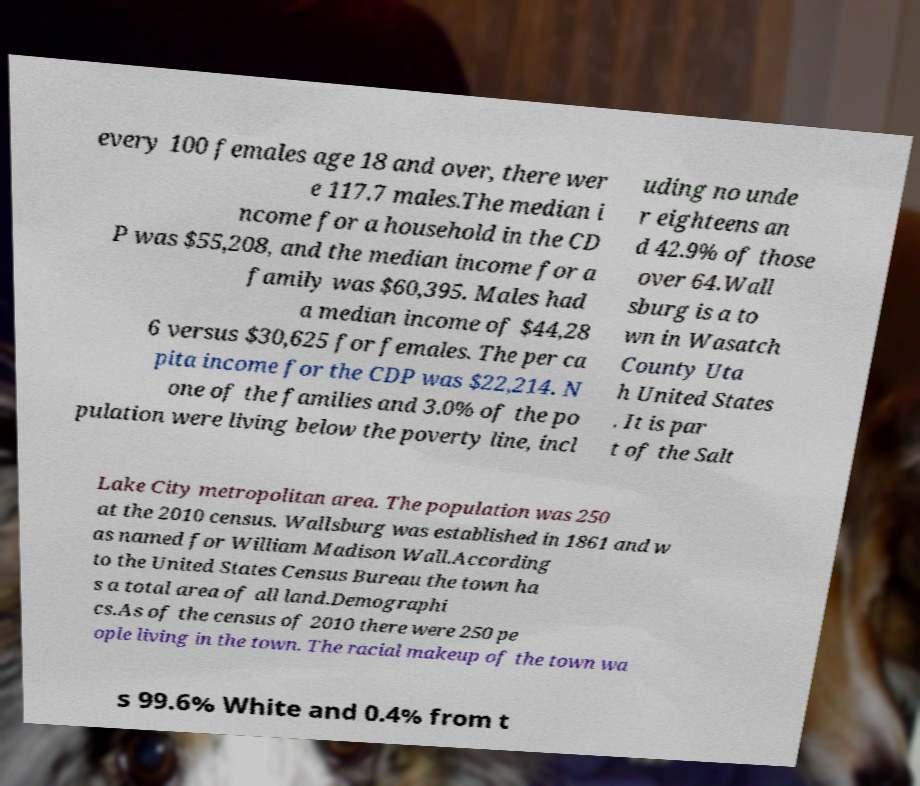For documentation purposes, I need the text within this image transcribed. Could you provide that? every 100 females age 18 and over, there wer e 117.7 males.The median i ncome for a household in the CD P was $55,208, and the median income for a family was $60,395. Males had a median income of $44,28 6 versus $30,625 for females. The per ca pita income for the CDP was $22,214. N one of the families and 3.0% of the po pulation were living below the poverty line, incl uding no unde r eighteens an d 42.9% of those over 64.Wall sburg is a to wn in Wasatch County Uta h United States . It is par t of the Salt Lake City metropolitan area. The population was 250 at the 2010 census. Wallsburg was established in 1861 and w as named for William Madison Wall.According to the United States Census Bureau the town ha s a total area of all land.Demographi cs.As of the census of 2010 there were 250 pe ople living in the town. The racial makeup of the town wa s 99.6% White and 0.4% from t 